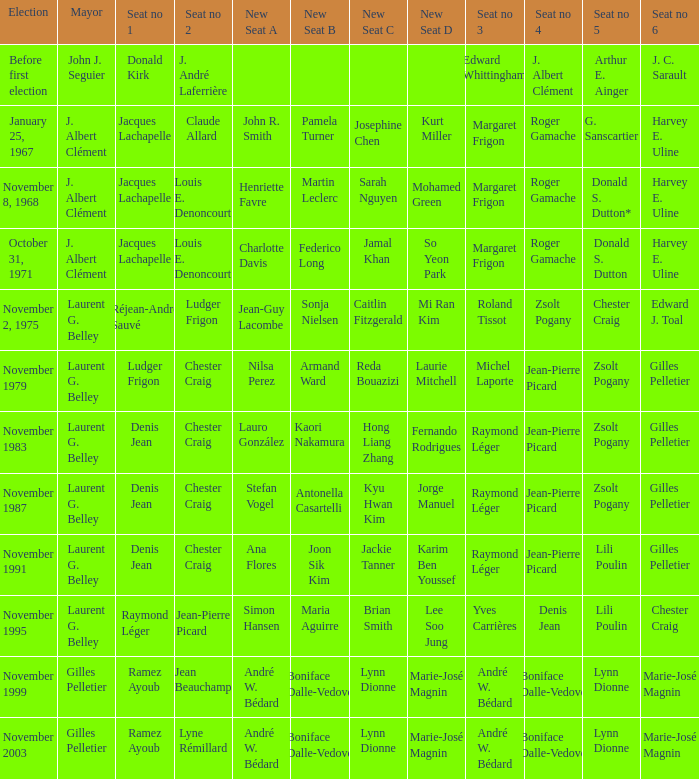Who was seat no 6 when seat no 1 and seat no 5 were jacques lachapelle and donald s. dutton Harvey E. Uline. 